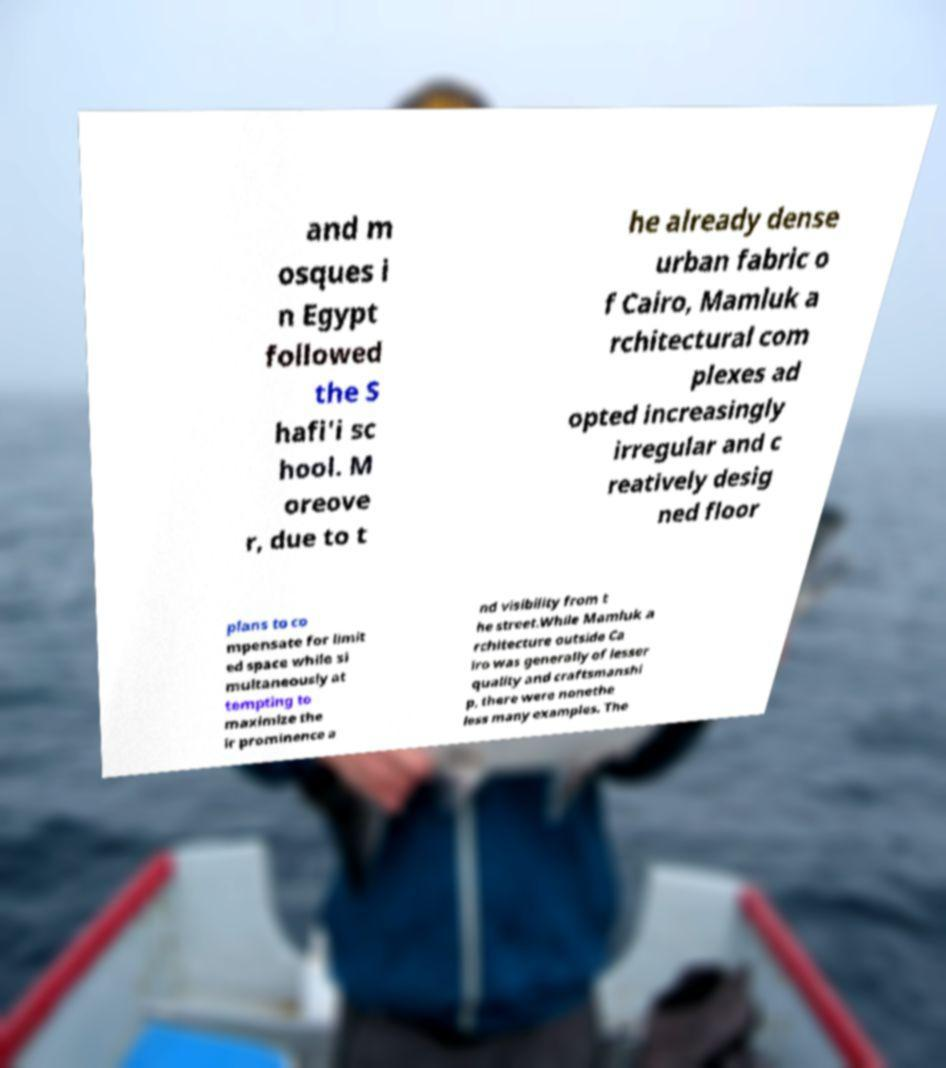Please identify and transcribe the text found in this image. and m osques i n Egypt followed the S hafi'i sc hool. M oreove r, due to t he already dense urban fabric o f Cairo, Mamluk a rchitectural com plexes ad opted increasingly irregular and c reatively desig ned floor plans to co mpensate for limit ed space while si multaneously at tempting to maximize the ir prominence a nd visibility from t he street.While Mamluk a rchitecture outside Ca iro was generally of lesser quality and craftsmanshi p, there were nonethe less many examples. The 